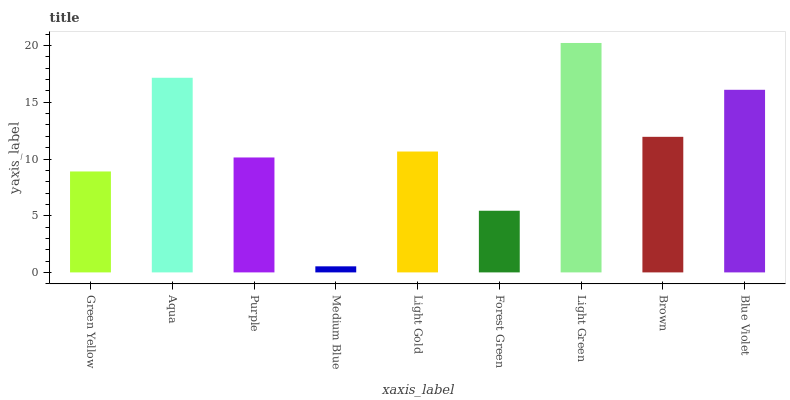Is Medium Blue the minimum?
Answer yes or no. Yes. Is Light Green the maximum?
Answer yes or no. Yes. Is Aqua the minimum?
Answer yes or no. No. Is Aqua the maximum?
Answer yes or no. No. Is Aqua greater than Green Yellow?
Answer yes or no. Yes. Is Green Yellow less than Aqua?
Answer yes or no. Yes. Is Green Yellow greater than Aqua?
Answer yes or no. No. Is Aqua less than Green Yellow?
Answer yes or no. No. Is Light Gold the high median?
Answer yes or no. Yes. Is Light Gold the low median?
Answer yes or no. Yes. Is Green Yellow the high median?
Answer yes or no. No. Is Forest Green the low median?
Answer yes or no. No. 